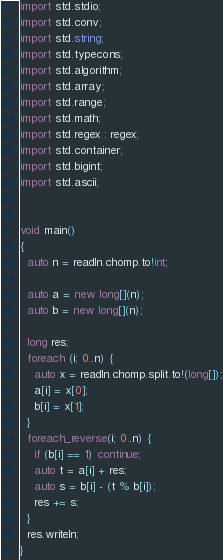<code> <loc_0><loc_0><loc_500><loc_500><_D_>import std.stdio;
import std.conv;
import std.string;
import std.typecons;
import std.algorithm;
import std.array;
import std.range;
import std.math;
import std.regex : regex;
import std.container;
import std.bigint;
import std.ascii;


void main()
{
  auto n = readln.chomp.to!int;

  auto a = new long[](n);
  auto b = new long[](n);

  long res;
  foreach (i; 0..n) {
    auto x = readln.chomp.split.to!(long[]);
    a[i] = x[0];
    b[i] = x[1];
  }
  foreach_reverse(i; 0..n) {
    if (b[i] == 1) continue;
    auto t = a[i] + res;
    auto s = b[i] - (t % b[i]);
    res += s;
  }
  res.writeln;
}
</code> 